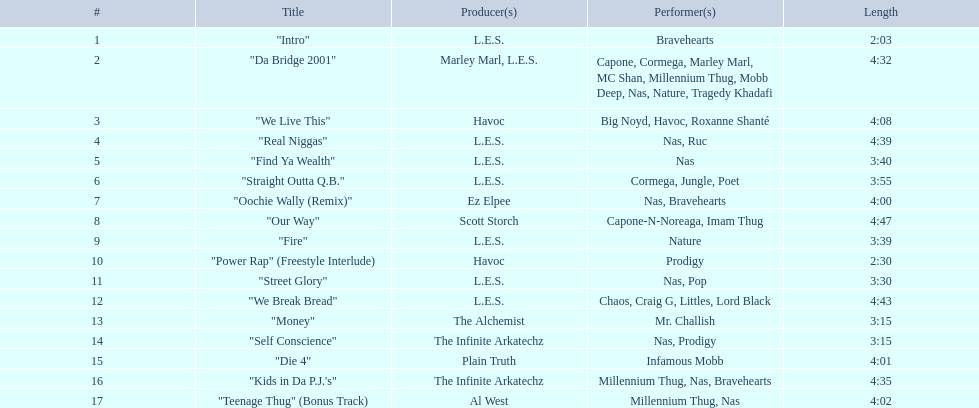What are the lengths of the songs? 2:03, 4:32, 4:08, 4:39, 3:40, 3:55, 4:00, 4:47, 3:39, 2:30, 3:30, 4:43, 3:15, 3:15, 4:01, 4:35, 4:02. Which one has the maximum duration? 4:47. 